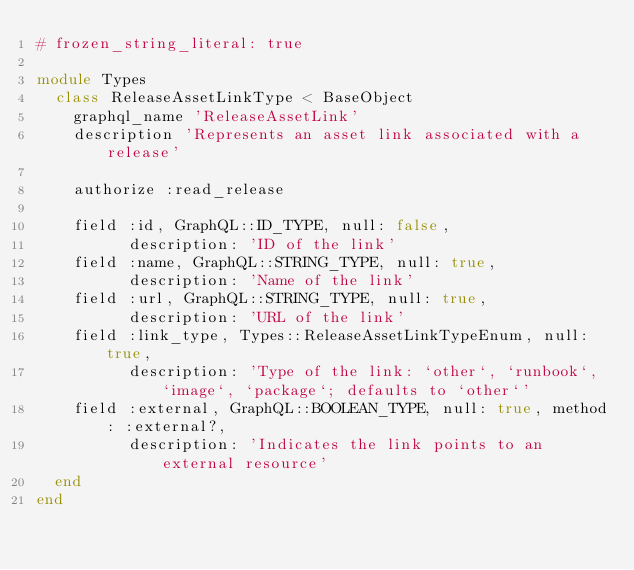<code> <loc_0><loc_0><loc_500><loc_500><_Ruby_># frozen_string_literal: true

module Types
  class ReleaseAssetLinkType < BaseObject
    graphql_name 'ReleaseAssetLink'
    description 'Represents an asset link associated with a release'

    authorize :read_release

    field :id, GraphQL::ID_TYPE, null: false,
          description: 'ID of the link'
    field :name, GraphQL::STRING_TYPE, null: true,
          description: 'Name of the link'
    field :url, GraphQL::STRING_TYPE, null: true,
          description: 'URL of the link'
    field :link_type, Types::ReleaseAssetLinkTypeEnum, null: true,
          description: 'Type of the link: `other`, `runbook`, `image`, `package`; defaults to `other`'
    field :external, GraphQL::BOOLEAN_TYPE, null: true, method: :external?,
          description: 'Indicates the link points to an external resource'
  end
end
</code> 